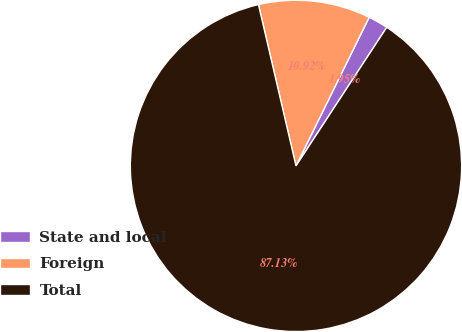Convert chart. <chart><loc_0><loc_0><loc_500><loc_500><pie_chart><fcel>State and local<fcel>Foreign<fcel>Total<nl><fcel>1.95%<fcel>10.92%<fcel>87.14%<nl></chart> 